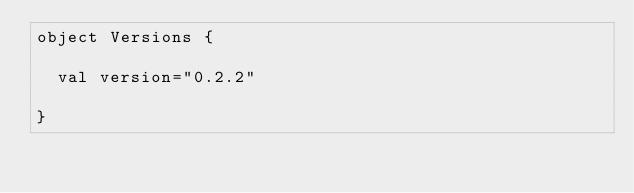Convert code to text. <code><loc_0><loc_0><loc_500><loc_500><_Scala_>object Versions {

  val version="0.2.2"

}
</code> 